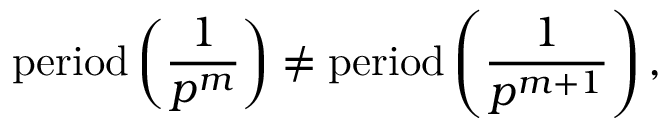Convert formula to latex. <formula><loc_0><loc_0><loc_500><loc_500>{ p e r i o d } \left ( { \frac { 1 } { p ^ { m } } } \right ) \neq { p e r i o d } \left ( { \frac { 1 } { p ^ { m + 1 } } } \right ) ,</formula> 